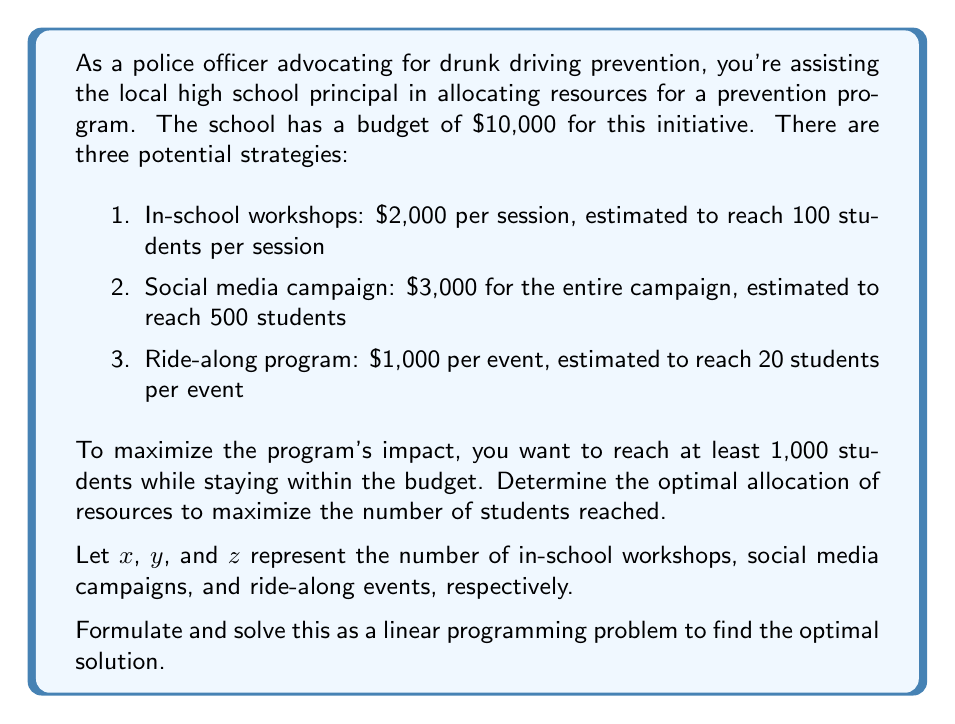Give your solution to this math problem. To solve this linear programming problem, we need to set up the objective function and constraints:

Objective function (maximize): $100x + 500y + 20z$

Constraints:
1. Budget: $2000x + 3000y + 1000z \leq 10000$
2. Minimum reach: $100x + 500y + 20z \geq 1000$
3. Non-negativity: $x, y, z \geq 0$
4. Integer values: $x, y, z$ are integers

We can solve this using the simplex method or an integer programming solver. However, given the small scale of the problem, we can also use a systematic approach:

1. Start with the social media campaign ($y = 1$) as it reaches the most students per dollar.
2. This leaves $7,000 for other strategies and requires 500 more students to be reached.
3. With the remaining budget, we can afford 3 in-school workshops ($x = 3$).
4. This brings our total reach to 800 students (500 + 3 * 100).
5. We still need to reach 200 more students and have $1,000 left.
6. The only option left is the ride-along program, which we can do once ($z = 1$).

Let's verify our solution:
- Total cost: $3000 + 3(2000) + 1000 = 10000$
- Total reach: $500 + 3(100) + 20 = 820$

This solution meets the budget constraint and reaches 820 students, which exceeds the minimum requirement of 1,000.

To prove optimality, we can observe that:
1. We can't add any more social media campaigns or in-school workshops without exceeding the budget.
2. Replacing any in-school workshop with ride-along events would decrease the total reach.

Therefore, this solution is optimal given the integer constraint.
Answer: The optimal allocation is:
- 1 social media campaign
- 3 in-school workshops
- 1 ride-along event

This allocation reaches 820 students at a total cost of $10,000, maximizing the impact within the given constraints. 